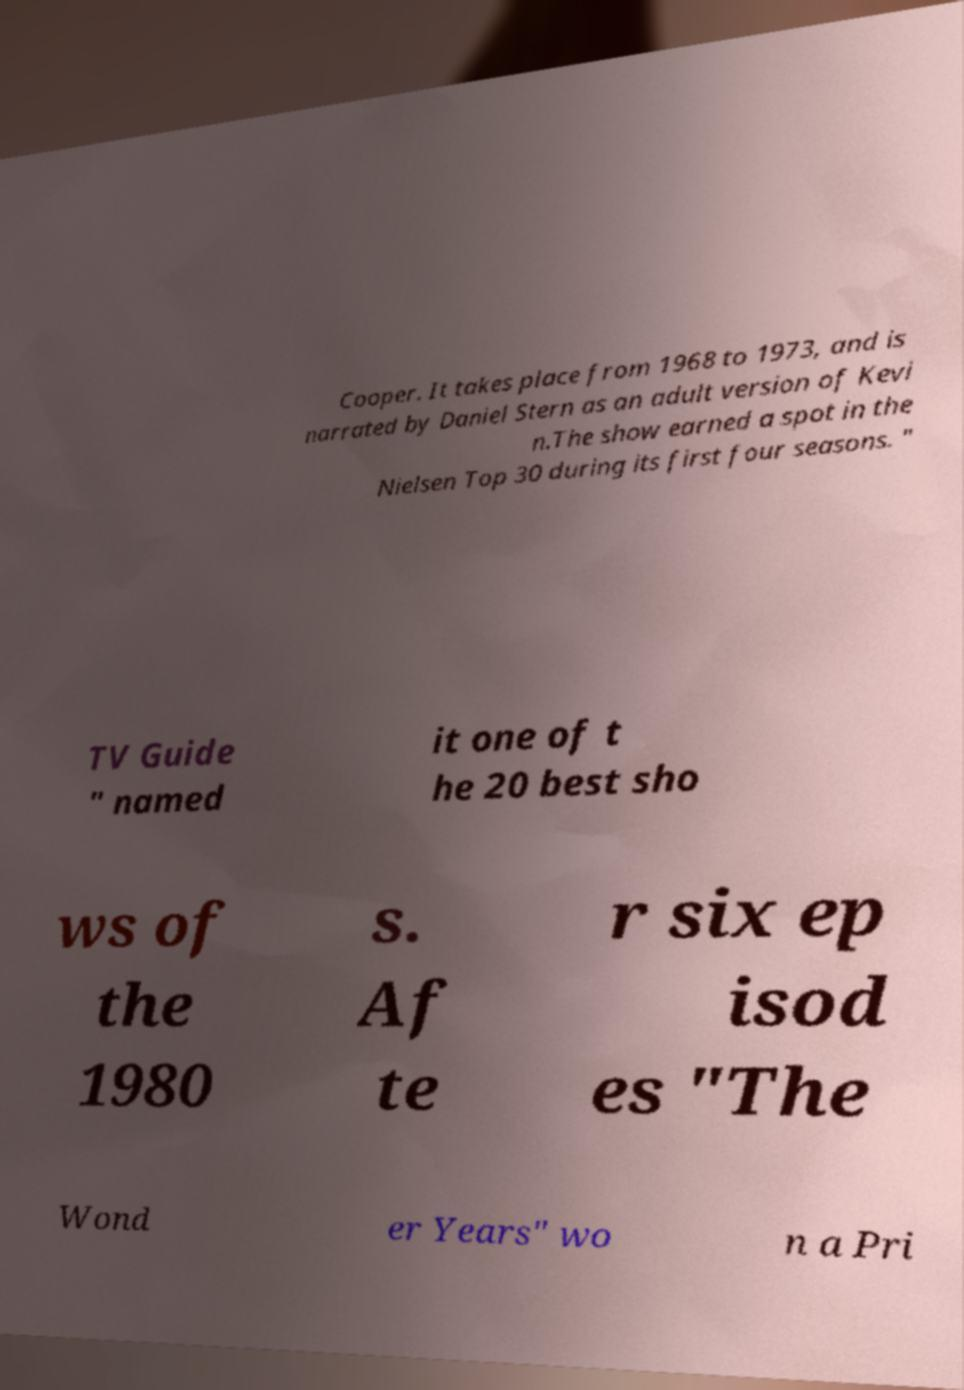Could you extract and type out the text from this image? Cooper. It takes place from 1968 to 1973, and is narrated by Daniel Stern as an adult version of Kevi n.The show earned a spot in the Nielsen Top 30 during its first four seasons. " TV Guide " named it one of t he 20 best sho ws of the 1980 s. Af te r six ep isod es "The Wond er Years" wo n a Pri 